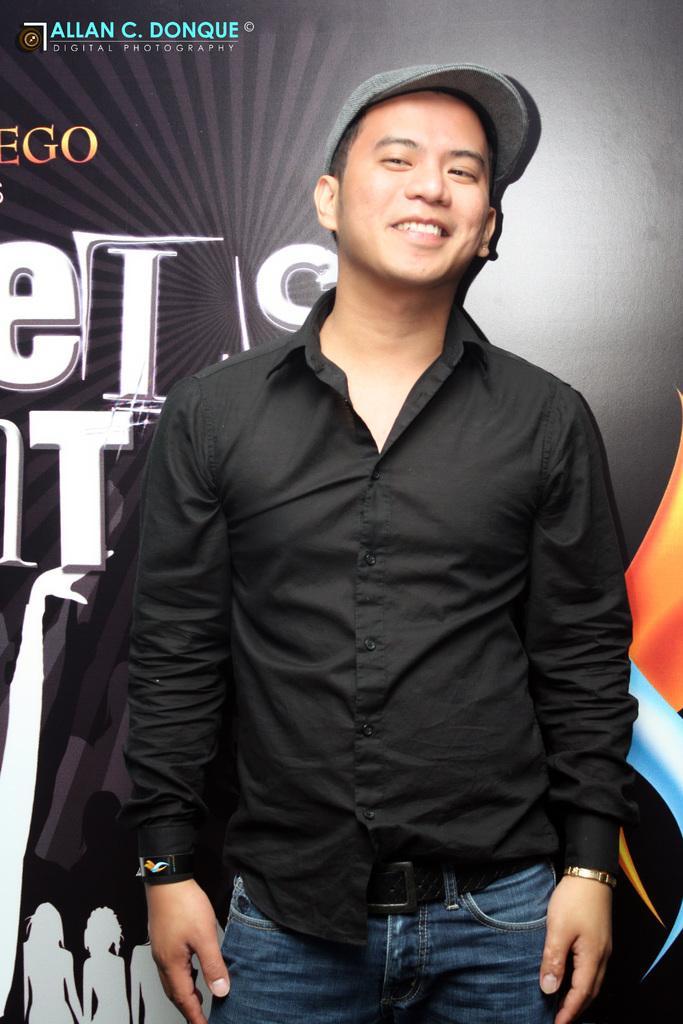Please provide a concise description of this image. In this image, there is a person wearing clothes and cap. There is a banner behind this person. 